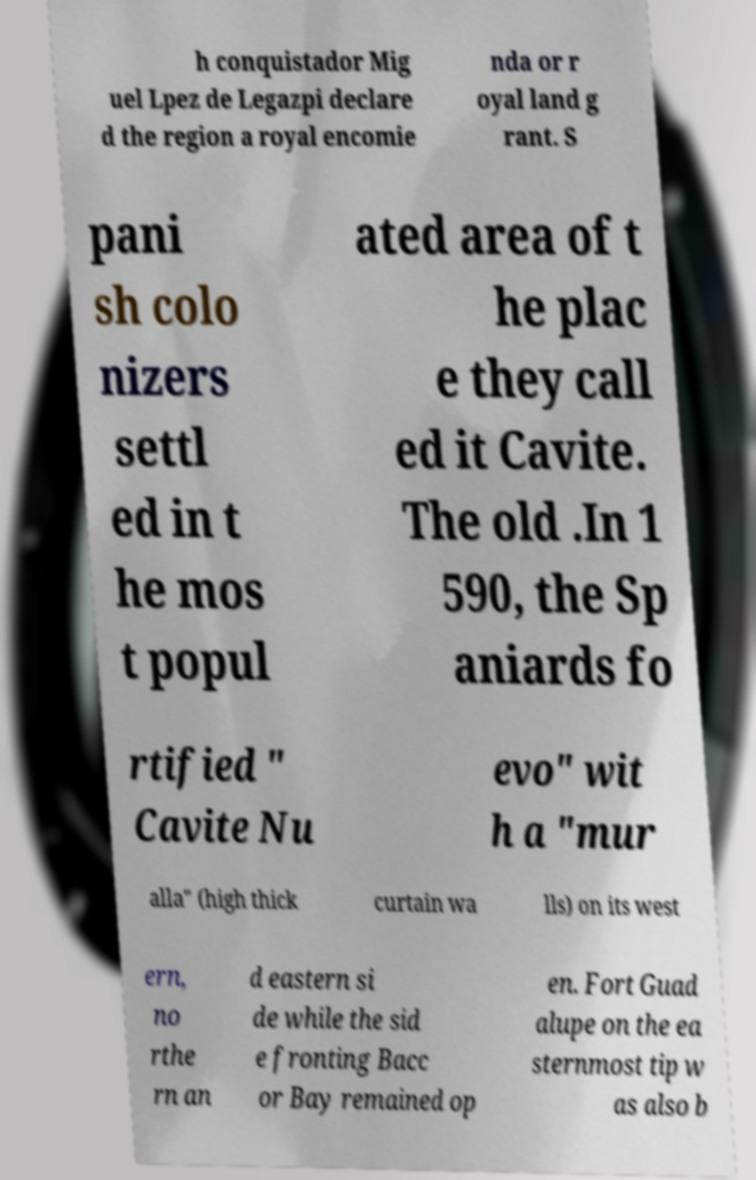Please identify and transcribe the text found in this image. h conquistador Mig uel Lpez de Legazpi declare d the region a royal encomie nda or r oyal land g rant. S pani sh colo nizers settl ed in t he mos t popul ated area of t he plac e they call ed it Cavite. The old .In 1 590, the Sp aniards fo rtified " Cavite Nu evo" wit h a "mur alla" (high thick curtain wa lls) on its west ern, no rthe rn an d eastern si de while the sid e fronting Bacc or Bay remained op en. Fort Guad alupe on the ea sternmost tip w as also b 